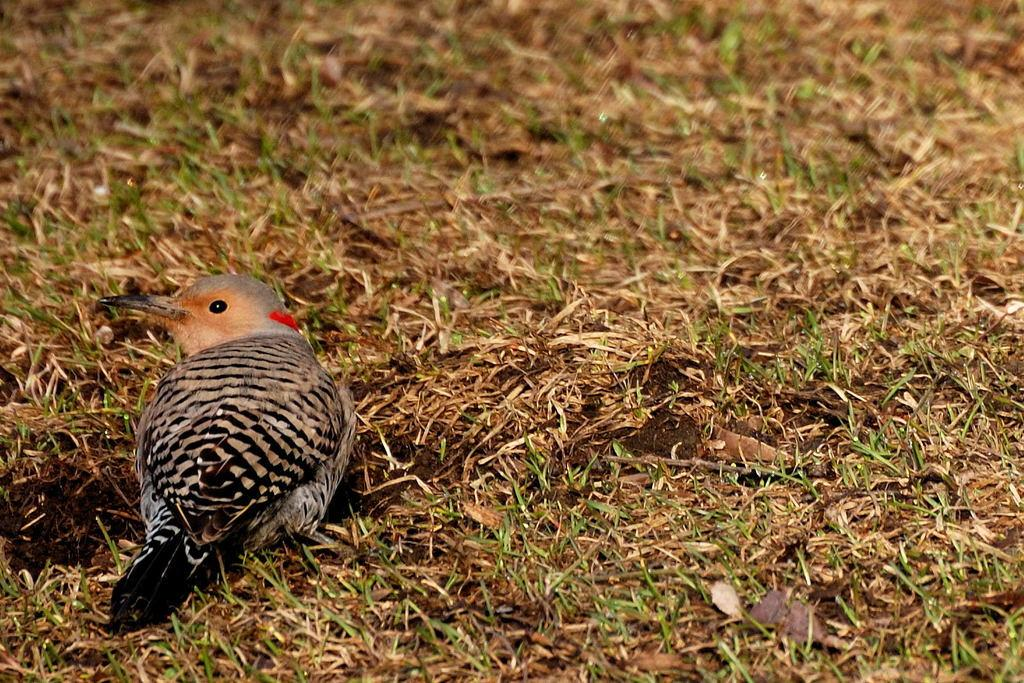What type of animal is in the image? There is a bird in the image. Where is the bird located? The bird is on the grass. Can you describe the background of the image? The background of the image is blurry. What type of shoes is the bird wearing in the image? There are no shoes present in the image, as birds do not wear shoes. 